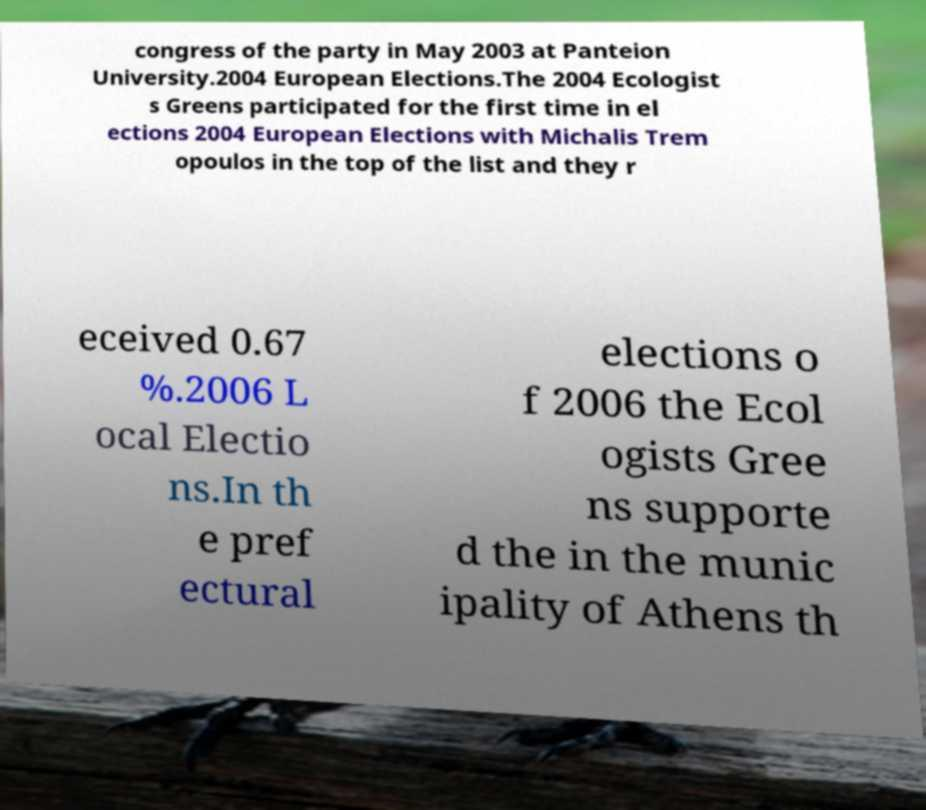Could you assist in decoding the text presented in this image and type it out clearly? congress of the party in May 2003 at Panteion University.2004 European Elections.The 2004 Ecologist s Greens participated for the first time in el ections 2004 European Elections with Michalis Trem opoulos in the top of the list and they r eceived 0.67 %.2006 L ocal Electio ns.In th e pref ectural elections o f 2006 the Ecol ogists Gree ns supporte d the in the munic ipality of Athens th 